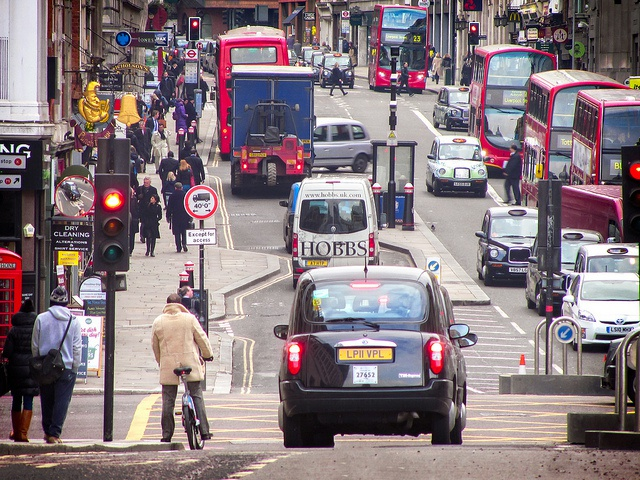Describe the objects in this image and their specific colors. I can see car in darkgray, black, lightgray, and gray tones, people in darkgray, black, and gray tones, truck in darkgray, darkblue, gray, navy, and black tones, car in darkgray, lightgray, gray, and black tones, and bus in darkgray, gray, lightgray, and black tones in this image. 